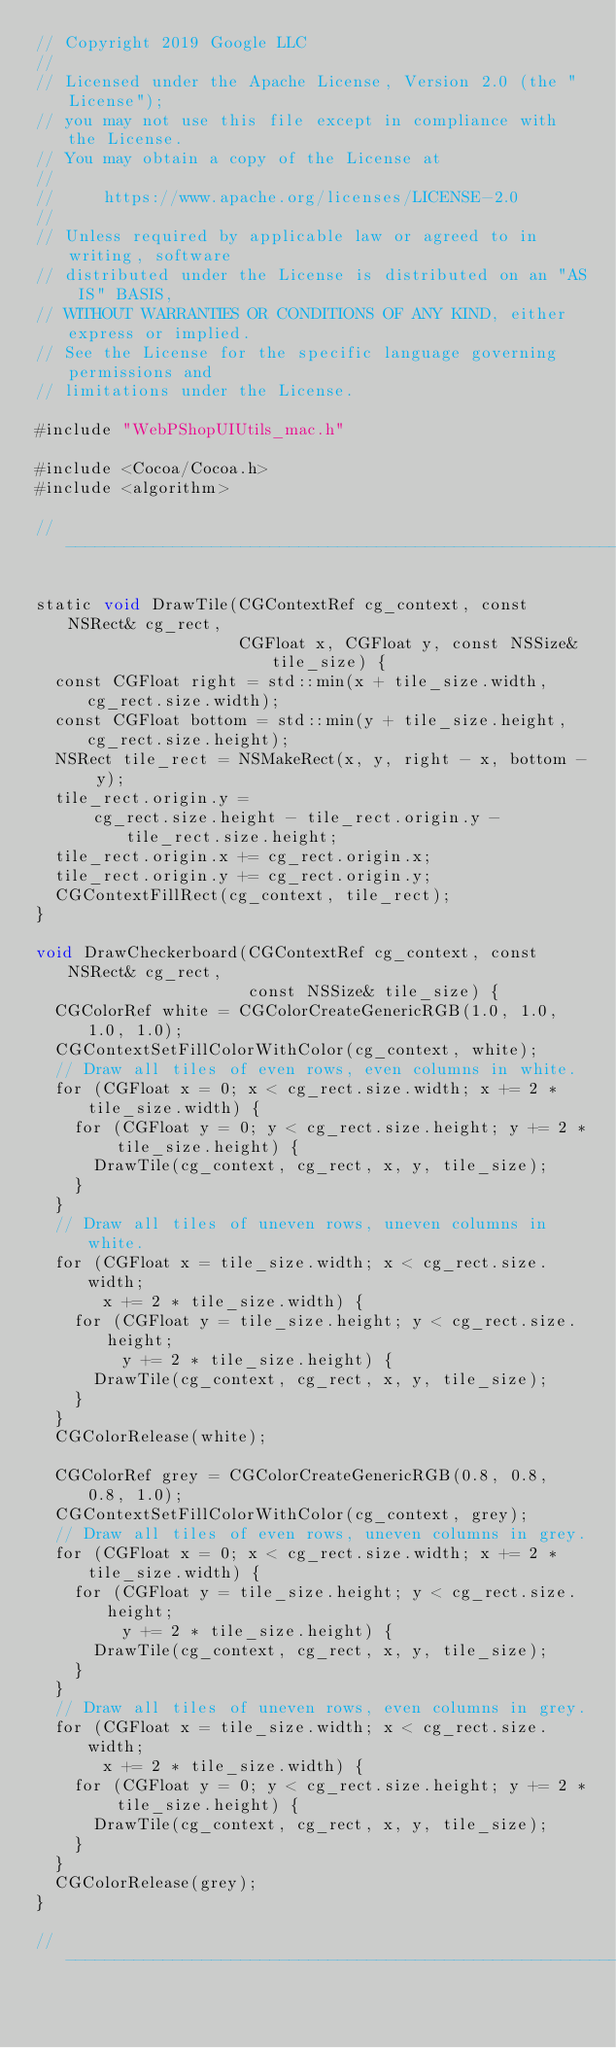Convert code to text. <code><loc_0><loc_0><loc_500><loc_500><_ObjectiveC_>// Copyright 2019 Google LLC
//
// Licensed under the Apache License, Version 2.0 (the "License");
// you may not use this file except in compliance with the License.
// You may obtain a copy of the License at
//
//     https://www.apache.org/licenses/LICENSE-2.0
//
// Unless required by applicable law or agreed to in writing, software
// distributed under the License is distributed on an "AS IS" BASIS,
// WITHOUT WARRANTIES OR CONDITIONS OF ANY KIND, either express or implied.
// See the License for the specific language governing permissions and
// limitations under the License.

#include "WebPShopUIUtils_mac.h"

#include <Cocoa/Cocoa.h>
#include <algorithm>

//------------------------------------------------------------------------------

static void DrawTile(CGContextRef cg_context, const NSRect& cg_rect,
                     CGFloat x, CGFloat y, const NSSize& tile_size) {
  const CGFloat right = std::min(x + tile_size.width, cg_rect.size.width);
  const CGFloat bottom = std::min(y + tile_size.height, cg_rect.size.height);
  NSRect tile_rect = NSMakeRect(x, y, right - x, bottom - y);
  tile_rect.origin.y =
      cg_rect.size.height - tile_rect.origin.y - tile_rect.size.height;
  tile_rect.origin.x += cg_rect.origin.x;
  tile_rect.origin.y += cg_rect.origin.y;
  CGContextFillRect(cg_context, tile_rect);
}

void DrawCheckerboard(CGContextRef cg_context, const NSRect& cg_rect,
                      const NSSize& tile_size) {
  CGColorRef white = CGColorCreateGenericRGB(1.0, 1.0, 1.0, 1.0);
  CGContextSetFillColorWithColor(cg_context, white);
  // Draw all tiles of even rows, even columns in white.
  for (CGFloat x = 0; x < cg_rect.size.width; x += 2 * tile_size.width) {
    for (CGFloat y = 0; y < cg_rect.size.height; y += 2 * tile_size.height) {
      DrawTile(cg_context, cg_rect, x, y, tile_size);
    }
  }
  // Draw all tiles of uneven rows, uneven columns in white.
  for (CGFloat x = tile_size.width; x < cg_rect.size.width;
       x += 2 * tile_size.width) {
    for (CGFloat y = tile_size.height; y < cg_rect.size.height;
         y += 2 * tile_size.height) {
      DrawTile(cg_context, cg_rect, x, y, tile_size);
    }
  }
  CGColorRelease(white);

  CGColorRef grey = CGColorCreateGenericRGB(0.8, 0.8, 0.8, 1.0);
  CGContextSetFillColorWithColor(cg_context, grey);
  // Draw all tiles of even rows, uneven columns in grey.
  for (CGFloat x = 0; x < cg_rect.size.width; x += 2 * tile_size.width) {
    for (CGFloat y = tile_size.height; y < cg_rect.size.height;
         y += 2 * tile_size.height) {
      DrawTile(cg_context, cg_rect, x, y, tile_size);
    }
  }
  // Draw all tiles of uneven rows, even columns in grey.
  for (CGFloat x = tile_size.width; x < cg_rect.size.width;
       x += 2 * tile_size.width) {
    for (CGFloat y = 0; y < cg_rect.size.height; y += 2 * tile_size.height) {
      DrawTile(cg_context, cg_rect, x, y, tile_size);
    }
  }
  CGColorRelease(grey);
}

//------------------------------------------------------------------------------
</code> 